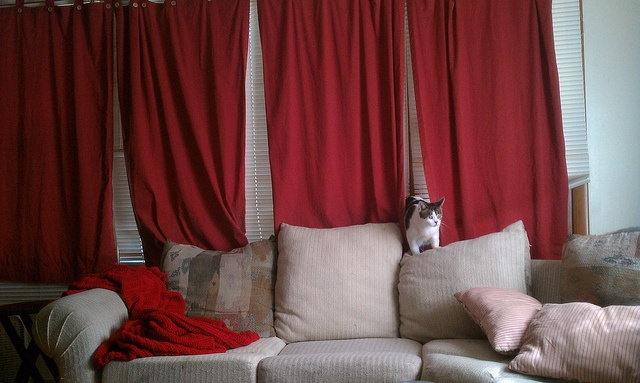Describe the objects in this image and their specific colors. I can see couch in black, darkgray, gray, and maroon tones and cat in black, gray, and darkgray tones in this image. 